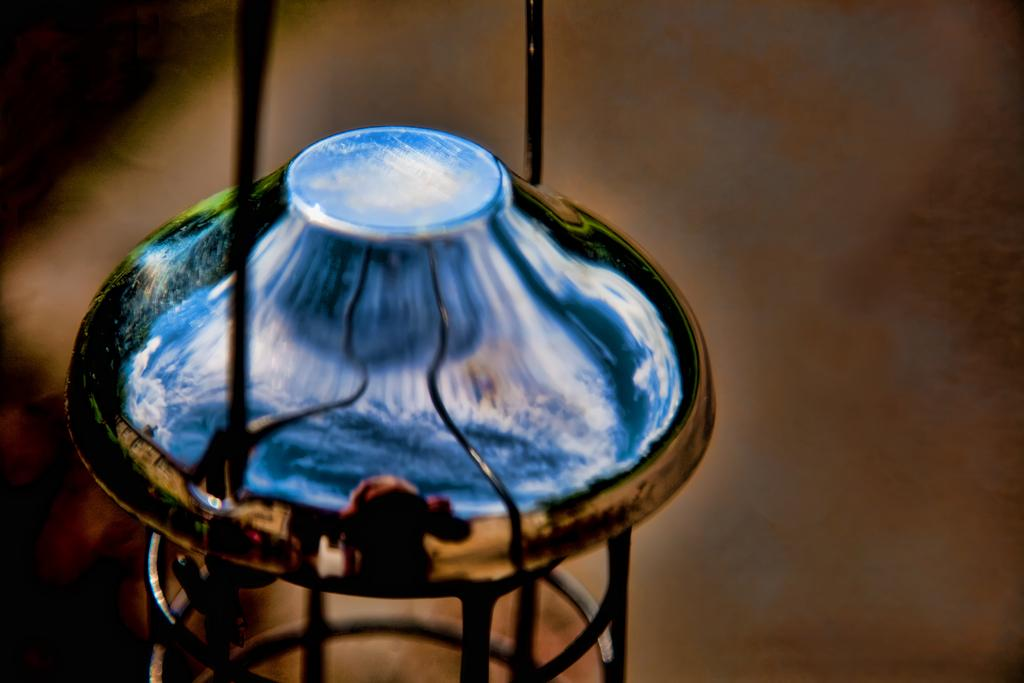What type of structure is present in the image? There is a metal cage in the image. Can you describe the location of the metal cage? The metal cage is placed on the ground. What is the relation between the metal cage and the cast in the image? There is no cast present in the image, and therefore no relation can be established between the metal cage and a cast. 